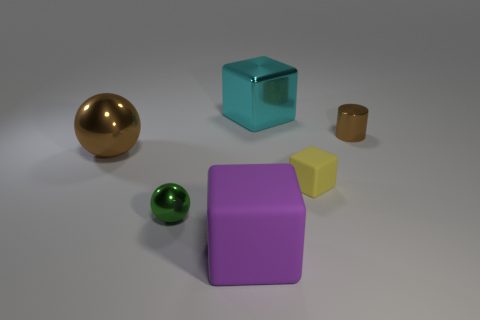Is the size of the purple thing the same as the brown metal thing to the right of the tiny rubber object?
Provide a short and direct response. No. There is a rubber cube behind the green metallic ball; are there any green metal things on the right side of it?
Give a very brief answer. No. The tiny shiny thing that is in front of the yellow matte cube has what shape?
Offer a very short reply. Sphere. There is a big sphere that is the same color as the small cylinder; what is its material?
Make the answer very short. Metal. There is a block on the left side of the large cube behind the small green metallic ball; what is its color?
Offer a very short reply. Purple. Do the yellow rubber cube and the brown cylinder have the same size?
Keep it short and to the point. Yes. There is another large thing that is the same shape as the green thing; what material is it?
Your answer should be compact. Metal. How many purple matte objects have the same size as the brown metallic cylinder?
Make the answer very short. 0. There is a tiny thing that is the same material as the purple block; what color is it?
Offer a terse response. Yellow. Are there fewer tiny yellow cubes than big red metal balls?
Keep it short and to the point. No. 